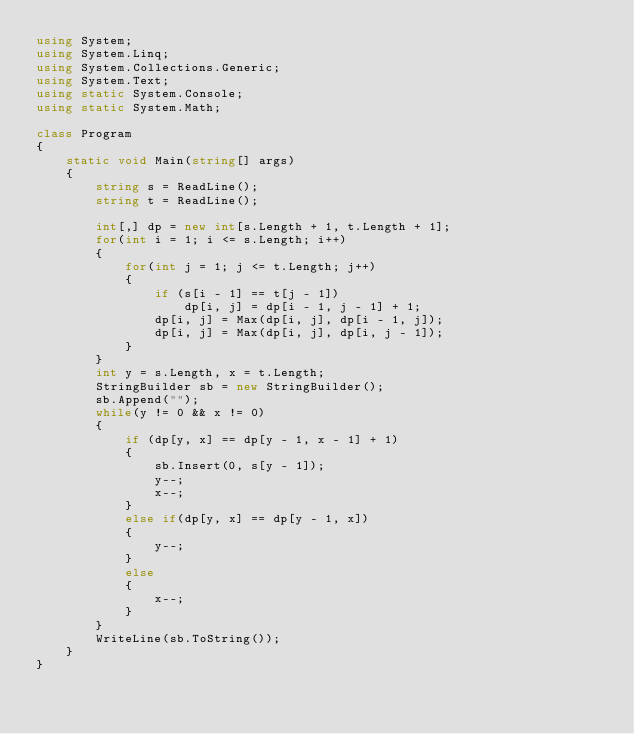<code> <loc_0><loc_0><loc_500><loc_500><_C#_>using System;
using System.Linq;
using System.Collections.Generic;
using System.Text;
using static System.Console;
using static System.Math;

class Program
{
    static void Main(string[] args)
    {
        string s = ReadLine();
        string t = ReadLine();

        int[,] dp = new int[s.Length + 1, t.Length + 1];
        for(int i = 1; i <= s.Length; i++)
        {
            for(int j = 1; j <= t.Length; j++)
            {
                if (s[i - 1] == t[j - 1])
                    dp[i, j] = dp[i - 1, j - 1] + 1;
                dp[i, j] = Max(dp[i, j], dp[i - 1, j]);
                dp[i, j] = Max(dp[i, j], dp[i, j - 1]);
            }
        }
        int y = s.Length, x = t.Length;
        StringBuilder sb = new StringBuilder();
        sb.Append("");
        while(y != 0 && x != 0)
        {
            if (dp[y, x] == dp[y - 1, x - 1] + 1)
            {
                sb.Insert(0, s[y - 1]);
                y--;
                x--;
            }
            else if(dp[y, x] == dp[y - 1, x])
            {
                y--;
            }
            else
            {
                x--;
            }
        }
        WriteLine(sb.ToString());
    }
}</code> 